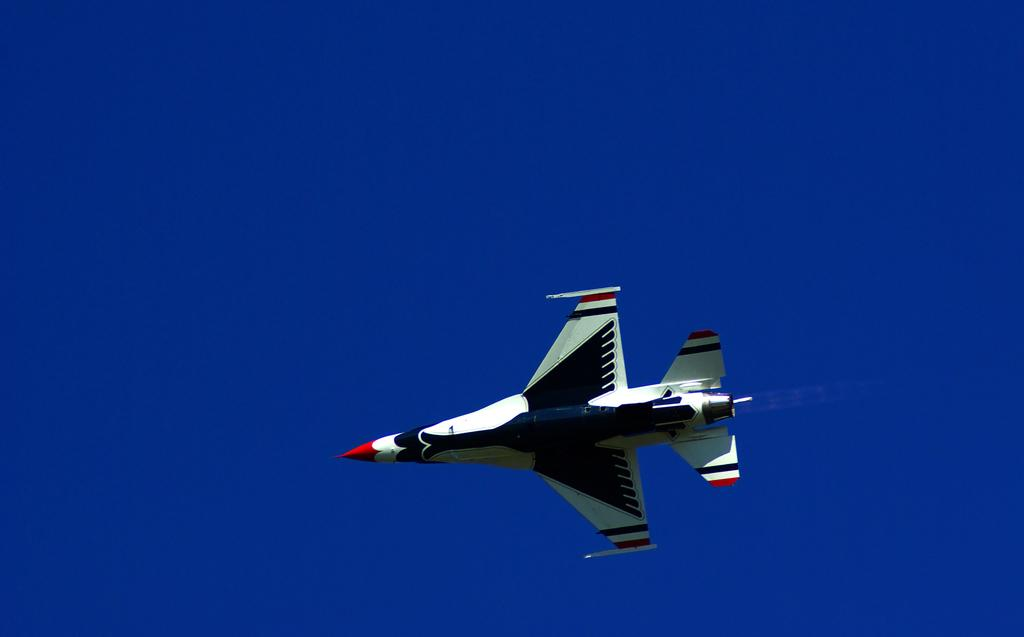What is the main subject of the image? The main subject of the image is an aircraft. What is the aircraft doing in the image? The aircraft is flying in the air. What colors can be seen on the aircraft? The aircraft is in white, blue, and red colors. What color is the background of the image? The background of the image is blue. Can you tell me how many heads of lettuce are visible in the image? There are no heads of lettuce present in the image; it features an aircraft flying in the air. 